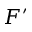Convert formula to latex. <formula><loc_0><loc_0><loc_500><loc_500>F ^ { \prime }</formula> 